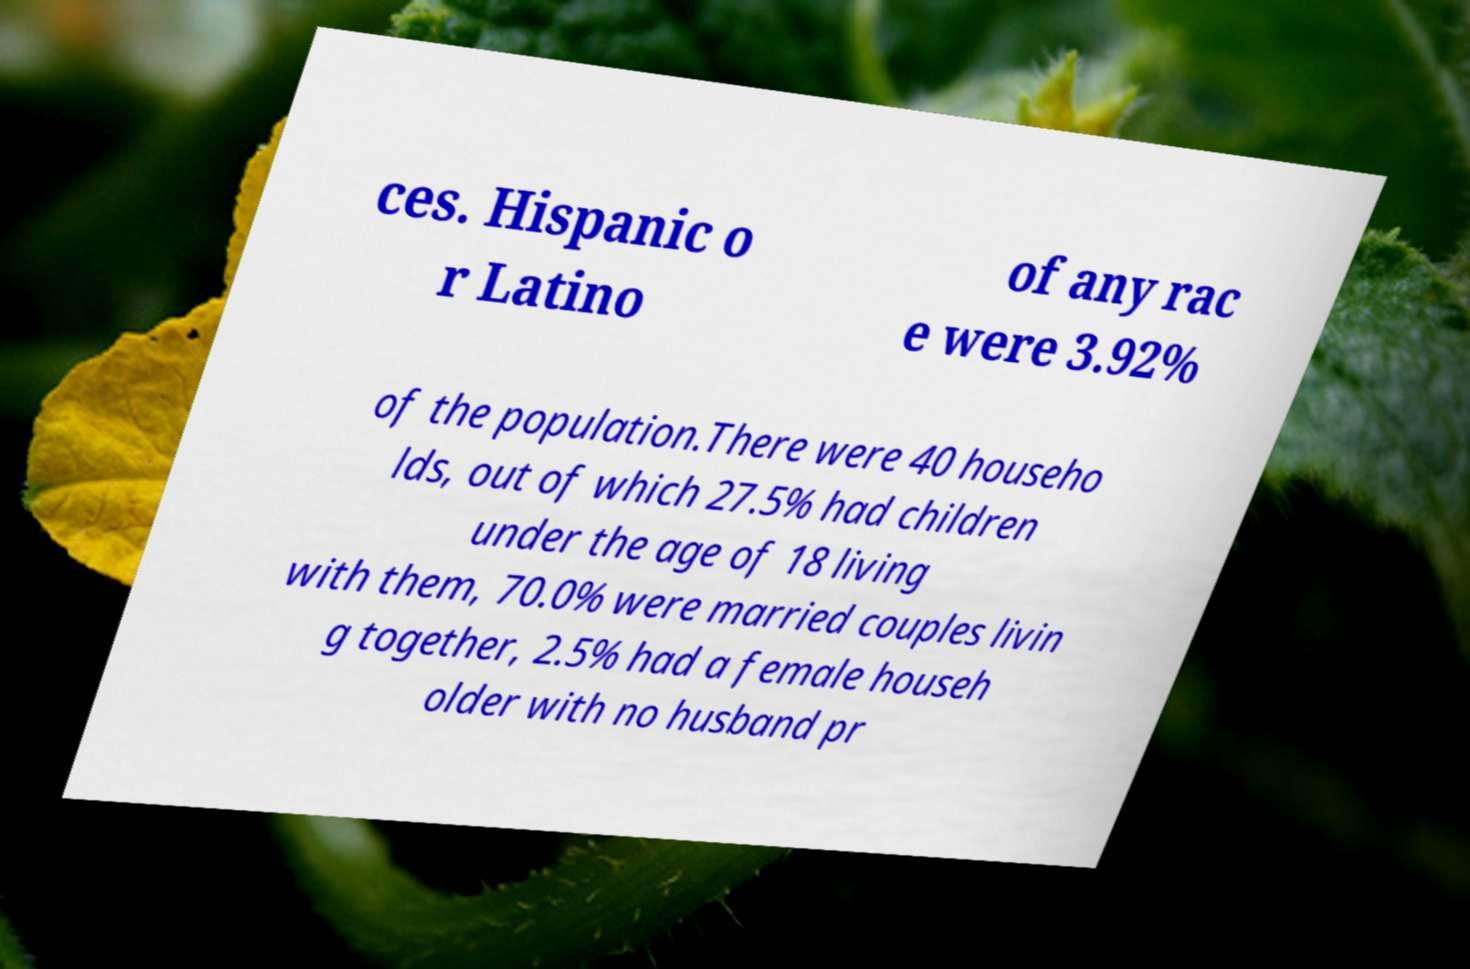Please read and relay the text visible in this image. What does it say? ces. Hispanic o r Latino of any rac e were 3.92% of the population.There were 40 househo lds, out of which 27.5% had children under the age of 18 living with them, 70.0% were married couples livin g together, 2.5% had a female househ older with no husband pr 